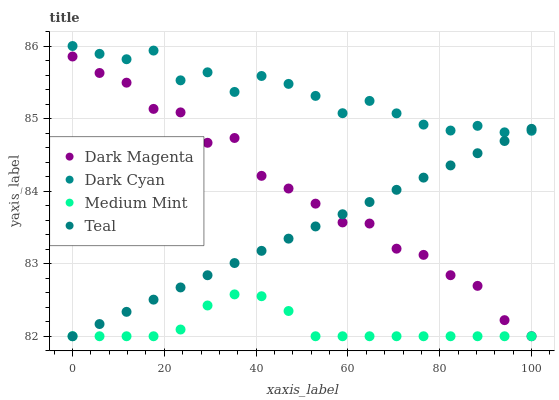Does Medium Mint have the minimum area under the curve?
Answer yes or no. Yes. Does Dark Cyan have the maximum area under the curve?
Answer yes or no. Yes. Does Dark Magenta have the minimum area under the curve?
Answer yes or no. No. Does Dark Magenta have the maximum area under the curve?
Answer yes or no. No. Is Teal the smoothest?
Answer yes or no. Yes. Is Dark Magenta the roughest?
Answer yes or no. Yes. Is Medium Mint the smoothest?
Answer yes or no. No. Is Medium Mint the roughest?
Answer yes or no. No. Does Medium Mint have the lowest value?
Answer yes or no. Yes. Does Dark Cyan have the highest value?
Answer yes or no. Yes. Does Dark Magenta have the highest value?
Answer yes or no. No. Is Dark Magenta less than Dark Cyan?
Answer yes or no. Yes. Is Dark Cyan greater than Dark Magenta?
Answer yes or no. Yes. Does Medium Mint intersect Dark Magenta?
Answer yes or no. Yes. Is Medium Mint less than Dark Magenta?
Answer yes or no. No. Is Medium Mint greater than Dark Magenta?
Answer yes or no. No. Does Dark Magenta intersect Dark Cyan?
Answer yes or no. No. 